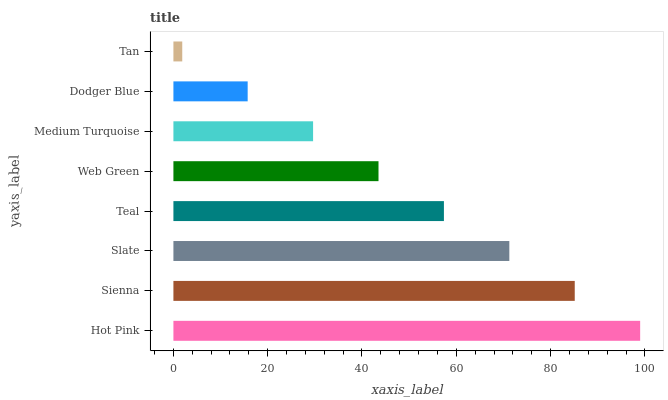Is Tan the minimum?
Answer yes or no. Yes. Is Hot Pink the maximum?
Answer yes or no. Yes. Is Sienna the minimum?
Answer yes or no. No. Is Sienna the maximum?
Answer yes or no. No. Is Hot Pink greater than Sienna?
Answer yes or no. Yes. Is Sienna less than Hot Pink?
Answer yes or no. Yes. Is Sienna greater than Hot Pink?
Answer yes or no. No. Is Hot Pink less than Sienna?
Answer yes or no. No. Is Teal the high median?
Answer yes or no. Yes. Is Web Green the low median?
Answer yes or no. Yes. Is Slate the high median?
Answer yes or no. No. Is Teal the low median?
Answer yes or no. No. 